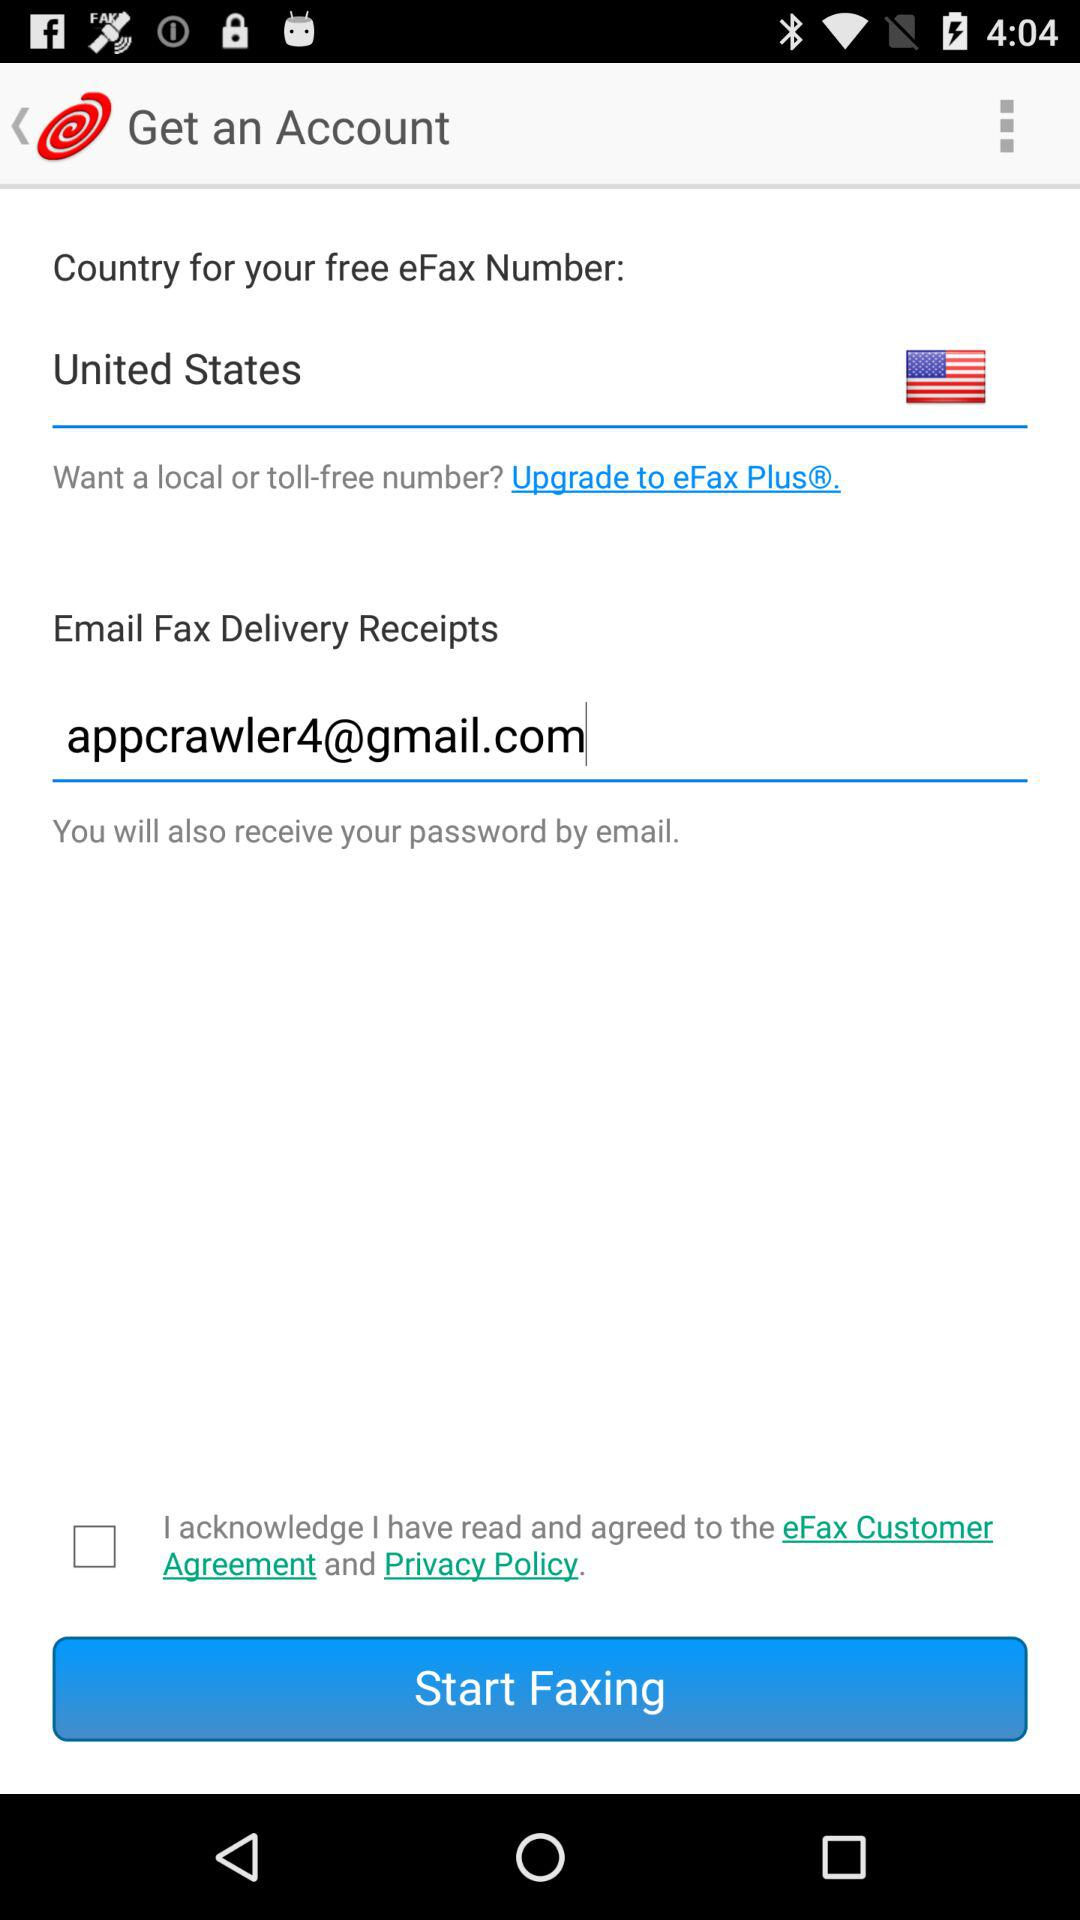What is the name of the country? The name of the country is the United States. 